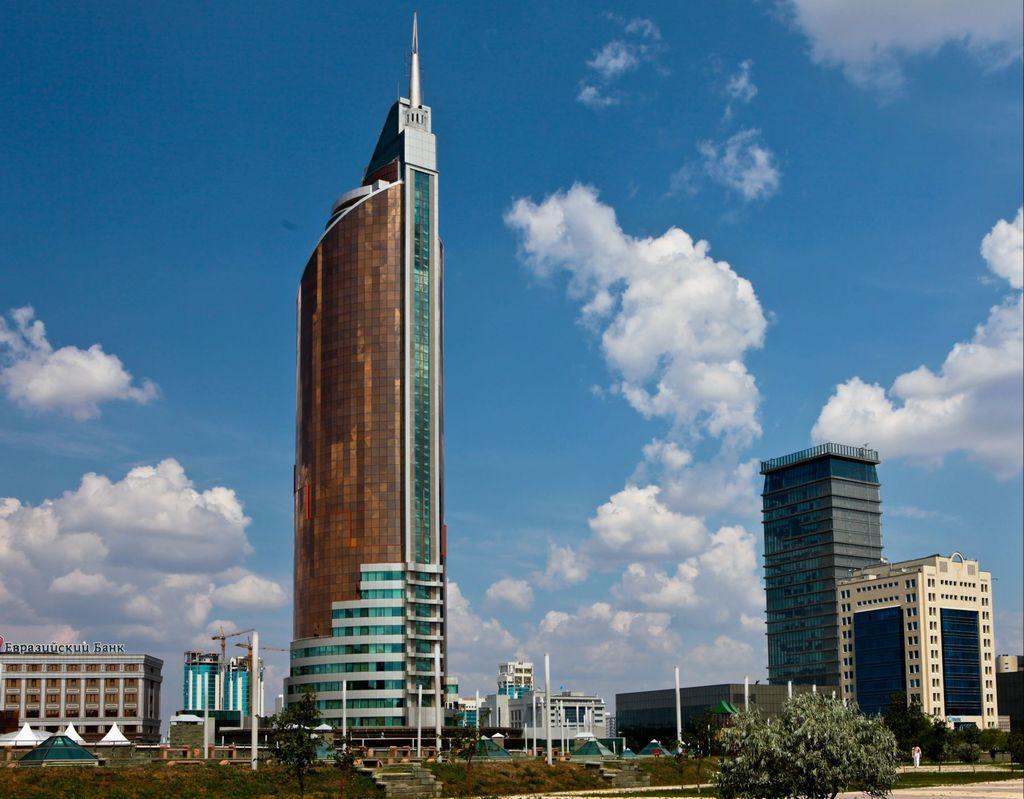How would you summarize this image in a sentence or two? There is a large storeyed building. In Front of this building there are some poles. There is a tree here. Beside the building there is a building. Beside the large storeyed building there is a cylinder shaped vessels. Beside the vessels there is another building. In the background we can observe sky and clouds 